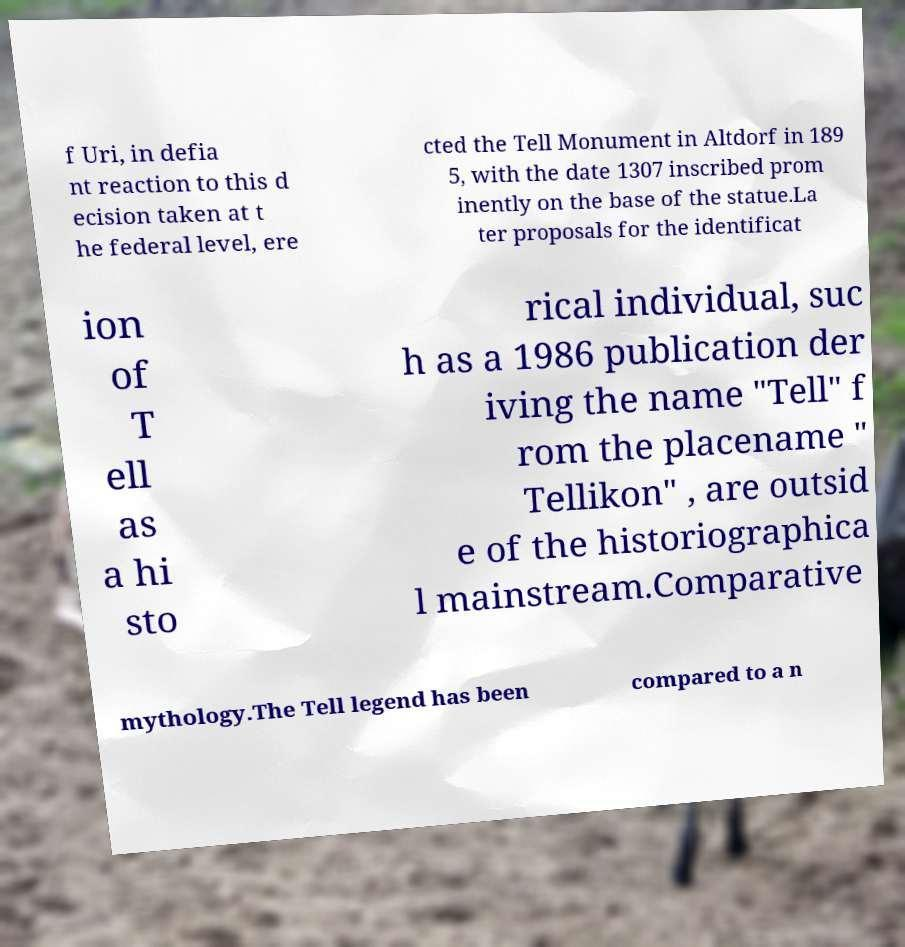Can you accurately transcribe the text from the provided image for me? f Uri, in defia nt reaction to this d ecision taken at t he federal level, ere cted the Tell Monument in Altdorf in 189 5, with the date 1307 inscribed prom inently on the base of the statue.La ter proposals for the identificat ion of T ell as a hi sto rical individual, suc h as a 1986 publication der iving the name "Tell" f rom the placename " Tellikon" , are outsid e of the historiographica l mainstream.Comparative mythology.The Tell legend has been compared to a n 